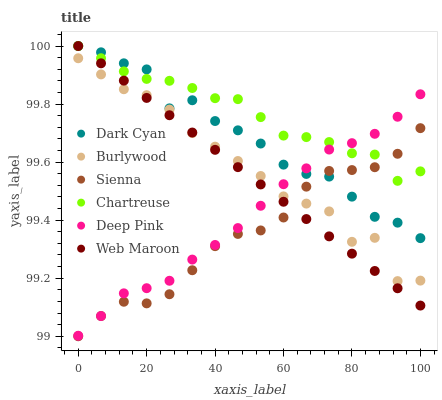Does Sienna have the minimum area under the curve?
Answer yes or no. Yes. Does Chartreuse have the maximum area under the curve?
Answer yes or no. Yes. Does Burlywood have the minimum area under the curve?
Answer yes or no. No. Does Burlywood have the maximum area under the curve?
Answer yes or no. No. Is Web Maroon the smoothest?
Answer yes or no. Yes. Is Burlywood the roughest?
Answer yes or no. Yes. Is Burlywood the smoothest?
Answer yes or no. No. Is Web Maroon the roughest?
Answer yes or no. No. Does Sienna have the lowest value?
Answer yes or no. Yes. Does Burlywood have the lowest value?
Answer yes or no. No. Does Dark Cyan have the highest value?
Answer yes or no. Yes. Does Burlywood have the highest value?
Answer yes or no. No. Is Burlywood less than Chartreuse?
Answer yes or no. Yes. Is Dark Cyan greater than Burlywood?
Answer yes or no. Yes. Does Chartreuse intersect Dark Cyan?
Answer yes or no. Yes. Is Chartreuse less than Dark Cyan?
Answer yes or no. No. Is Chartreuse greater than Dark Cyan?
Answer yes or no. No. Does Burlywood intersect Chartreuse?
Answer yes or no. No. 